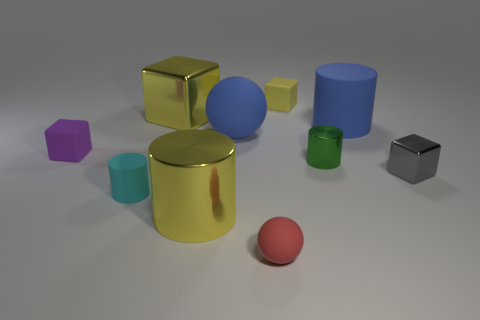There is a rubber ball behind the big shiny cylinder; what number of tiny objects are to the right of it?
Offer a very short reply. 4. What number of objects are either rubber cylinders to the right of the big yellow shiny cylinder or big rubber things that are on the right side of the small green shiny cylinder?
Provide a succinct answer. 1. What material is the tiny purple thing that is the same shape as the small yellow object?
Offer a very short reply. Rubber. How many objects are balls that are to the left of the red rubber sphere or green cylinders?
Make the answer very short. 2. The purple thing that is the same material as the tiny ball is what shape?
Make the answer very short. Cube. How many small cyan matte things are the same shape as the green metallic thing?
Your response must be concise. 1. What is the material of the small red object?
Give a very brief answer. Rubber. Is the color of the big metal block the same as the shiny cylinder on the left side of the small shiny cylinder?
Offer a very short reply. Yes. What number of cylinders are either blue matte objects or tiny gray metal objects?
Your answer should be compact. 1. There is a shiny block that is left of the yellow cylinder; what is its color?
Give a very brief answer. Yellow. 